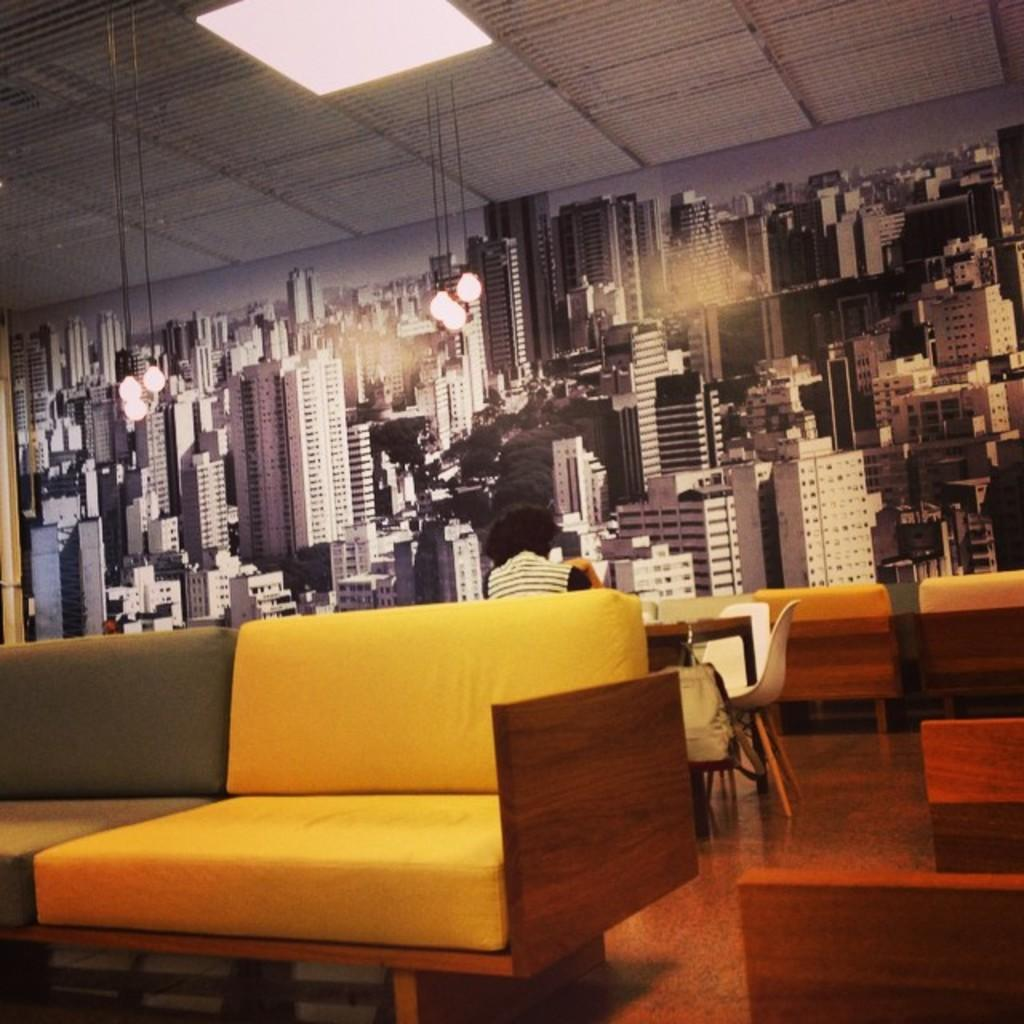What is the main subject of the image? There is a person sitting in front of a table in the image. Where is the table located in relation to the person? The table is in the center of the image. What is in front of the person? There is a couch in front of the person. What can be seen in the background of the image? There is a wall visible in the background. What type of ice can be seen melting on the person's forehead in the image? There is no ice present in the image, and therefore no such activity can be observed. 